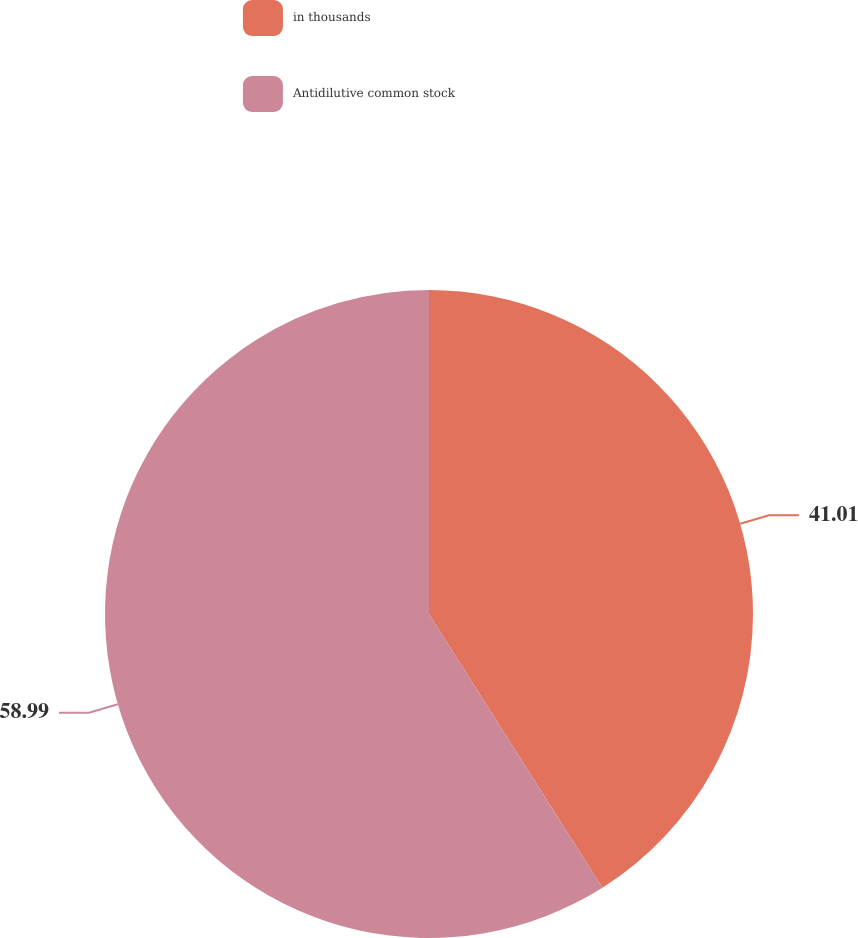<chart> <loc_0><loc_0><loc_500><loc_500><pie_chart><fcel>in thousands<fcel>Antidilutive common stock<nl><fcel>41.01%<fcel>58.99%<nl></chart> 